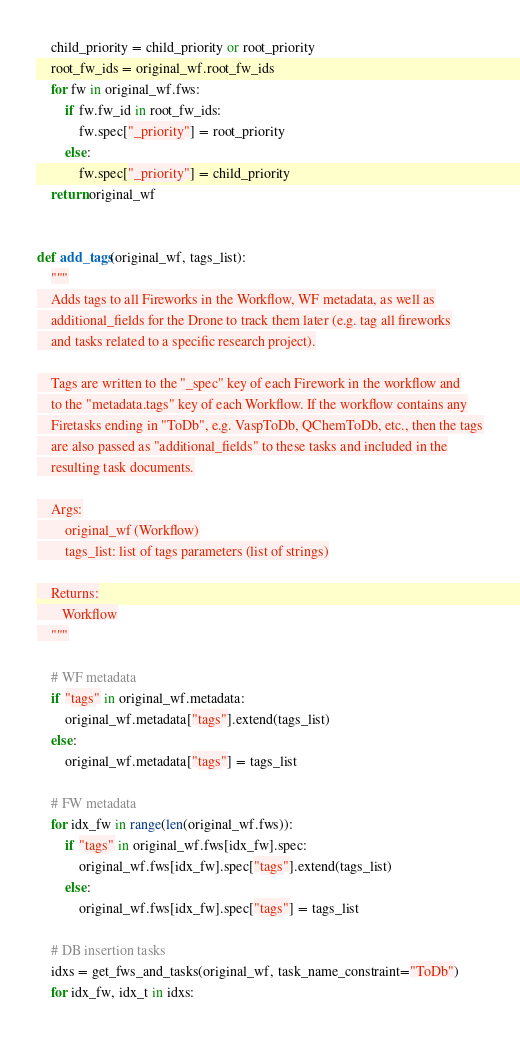<code> <loc_0><loc_0><loc_500><loc_500><_Python_>    child_priority = child_priority or root_priority
    root_fw_ids = original_wf.root_fw_ids
    for fw in original_wf.fws:
        if fw.fw_id in root_fw_ids:
            fw.spec["_priority"] = root_priority
        else:
            fw.spec["_priority"] = child_priority
    return original_wf


def add_tags(original_wf, tags_list):
    """
    Adds tags to all Fireworks in the Workflow, WF metadata, as well as
    additional_fields for the Drone to track them later (e.g. tag all fireworks
    and tasks related to a specific research project).

    Tags are written to the "_spec" key of each Firework in the workflow and
    to the "metadata.tags" key of each Workflow. If the workflow contains any
    Firetasks ending in "ToDb", e.g. VaspToDb, QChemToDb, etc., then the tags
    are also passed as "additional_fields" to these tasks and included in the
    resulting task documents.

    Args:
        original_wf (Workflow)
        tags_list: list of tags parameters (list of strings)

    Returns:
       Workflow
    """

    # WF metadata
    if "tags" in original_wf.metadata:
        original_wf.metadata["tags"].extend(tags_list)
    else:
        original_wf.metadata["tags"] = tags_list

    # FW metadata
    for idx_fw in range(len(original_wf.fws)):
        if "tags" in original_wf.fws[idx_fw].spec:
            original_wf.fws[idx_fw].spec["tags"].extend(tags_list)
        else:
            original_wf.fws[idx_fw].spec["tags"] = tags_list

    # DB insertion tasks
    idxs = get_fws_and_tasks(original_wf, task_name_constraint="ToDb")
    for idx_fw, idx_t in idxs:</code> 